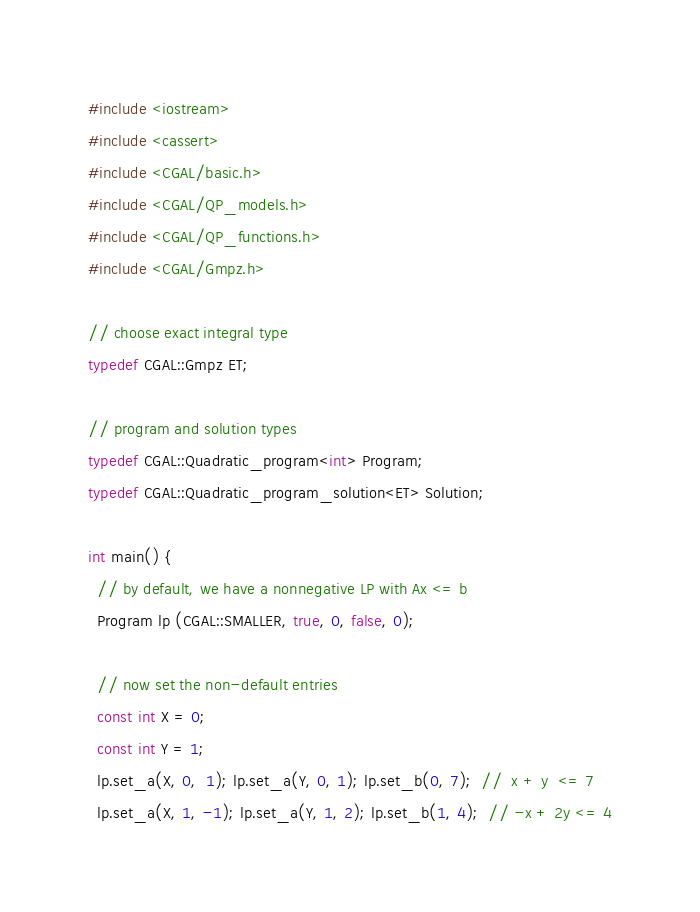<code> <loc_0><loc_0><loc_500><loc_500><_C++_>#include <iostream>
#include <cassert>
#include <CGAL/basic.h>
#include <CGAL/QP_models.h>
#include <CGAL/QP_functions.h>
#include <CGAL/Gmpz.h>

// choose exact integral type
typedef CGAL::Gmpz ET;

// program and solution types
typedef CGAL::Quadratic_program<int> Program;
typedef CGAL::Quadratic_program_solution<ET> Solution;

int main() {
  // by default, we have a nonnegative LP with Ax <= b
  Program lp (CGAL::SMALLER, true, 0, false, 0);

  // now set the non-default entries
  const int X = 0;
  const int Y = 1;
  lp.set_a(X, 0,  1); lp.set_a(Y, 0, 1); lp.set_b(0, 7);  //  x + y  <= 7
  lp.set_a(X, 1, -1); lp.set_a(Y, 1, 2); lp.set_b(1, 4);  // -x + 2y <= 4</code> 